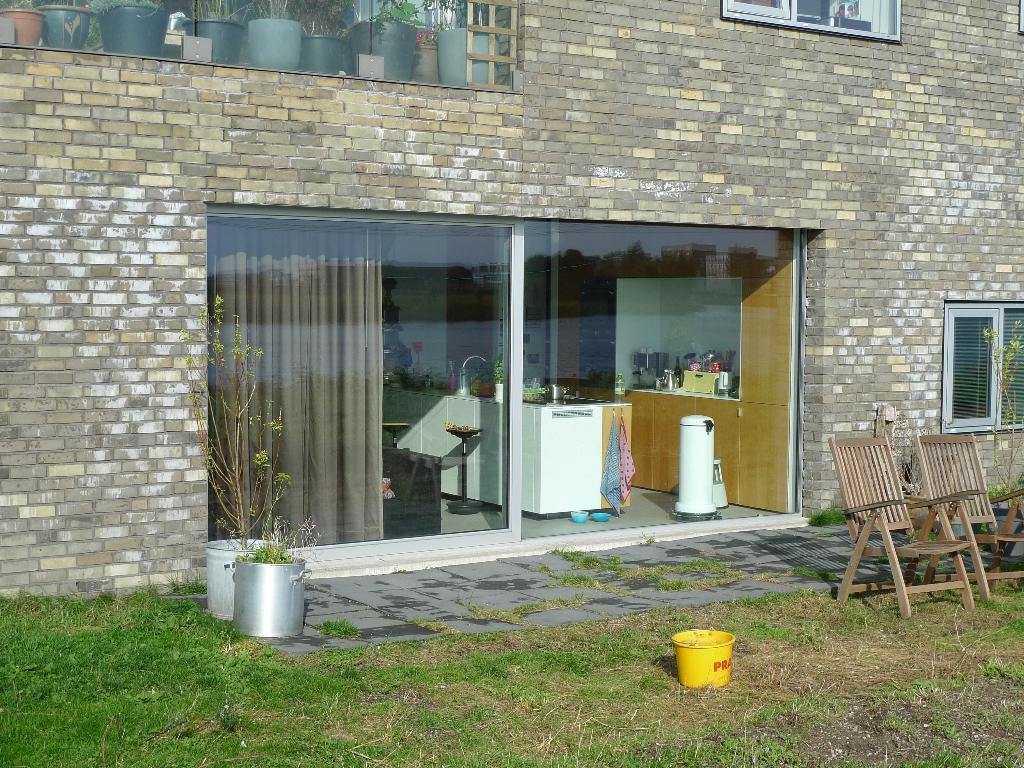What type of structure is visible in the image? There is a brick wall in the image. What can be seen on the brick wall? There are windows in the image. What objects are present in the image? There are glasses, plants, chairs, and a container in the image. What is the ground made of in the image? There is grass visible in the image. What can be seen through the glasses in the image? Through the glasses, plants, a curtain, a cupboard, a table, and other objects are visible. Can you tell me how many steps the kitty takes in the image? There is no kitty present in the image, so it is not possible to determine how many steps it takes. What sense is being used by the objects in the image? The provided facts do not mention any specific senses being used by the objects in the image. 